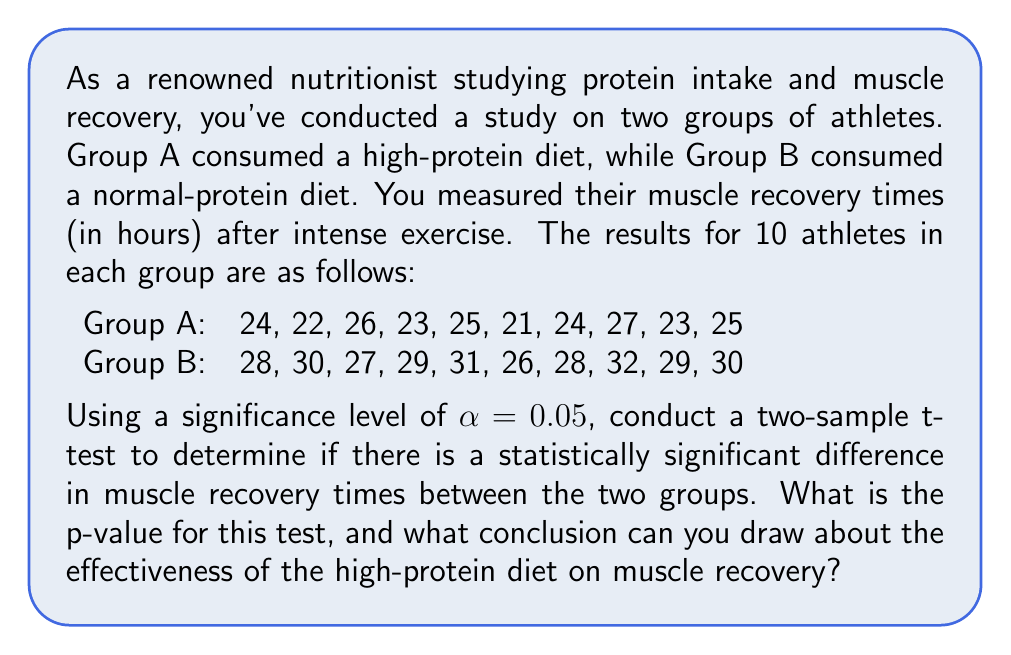Could you help me with this problem? To solve this problem, we'll follow these steps:

1. Calculate the means and standard deviations for both groups.
2. Calculate the pooled standard deviation.
3. Calculate the t-statistic.
4. Determine the degrees of freedom.
5. Calculate the p-value.
6. Compare the p-value to the significance level and draw a conclusion.

Step 1: Calculate means and standard deviations

Group A:
Mean: $\bar{X}_A = \frac{24 + 22 + 26 + 23 + 25 + 21 + 24 + 27 + 23 + 25}{10} = 24$
Standard deviation: $s_A = \sqrt{\frac{\sum (X_A - \bar{X}_A)^2}{n_A - 1}} = 1.826$

Group B:
Mean: $\bar{X}_B = \frac{28 + 30 + 27 + 29 + 31 + 26 + 28 + 32 + 29 + 30}{10} = 29$
Standard deviation: $s_B = \sqrt{\frac{\sum (X_B - \bar{X}_B)^2}{n_B - 1}} = 1.886$

Step 2: Calculate pooled standard deviation

$$s_p = \sqrt{\frac{(n_A - 1)s_A^2 + (n_B - 1)s_B^2}{n_A + n_B - 2}}$$
$$s_p = \sqrt{\frac{(10 - 1)(1.826)^2 + (10 - 1)(1.886)^2}{10 + 10 - 2}} = 1.856$$

Step 3: Calculate t-statistic

$$t = \frac{\bar{X}_A - \bar{X}_B}{s_p \sqrt{\frac{2}{n}}} = \frac{24 - 29}{1.856 \sqrt{\frac{2}{10}}} = -6.749$$

Step 4: Determine degrees of freedom

$df = n_A + n_B - 2 = 10 + 10 - 2 = 18$

Step 5: Calculate p-value

Using a t-distribution table or calculator with 18 degrees of freedom and a two-tailed test, we find:

$p-value = 2 \times P(T \leq -6.749) \approx 2.32 \times 10^{-6}$

Step 6: Compare p-value to significance level and draw conclusion

Since the p-value $(2.32 \times 10^{-6})$ is less than the significance level $(\alpha = 0.05)$, we reject the null hypothesis.
Answer: The p-value for this test is approximately $2.32 \times 10^{-6}$. Since this is less than the significance level of 0.05, we conclude that there is a statistically significant difference in muscle recovery times between the two groups. This suggests that the high-protein diet may be effective in reducing muscle recovery time for athletes. 